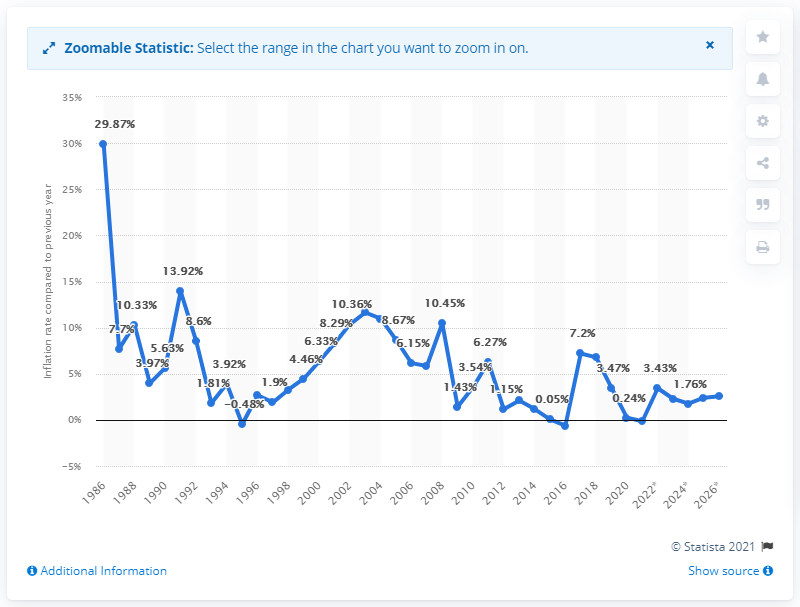Outline some significant characteristics in this image. In 2020, the inflation rate in Tonga was 0.24%. 